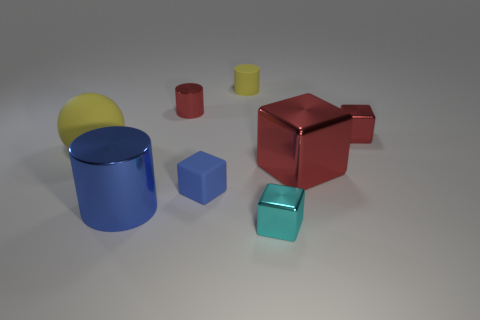What is the material of the red cube that is the same size as the blue rubber cube?
Give a very brief answer. Metal. What number of small red things are there?
Ensure brevity in your answer.  2. There is a red metal cube behind the large yellow thing; what is its size?
Give a very brief answer. Small. Are there the same number of small cyan metallic blocks to the right of the cyan metallic thing and big yellow balls?
Your answer should be compact. No. Are there any big yellow rubber objects of the same shape as the blue matte object?
Offer a terse response. No. There is a shiny thing that is behind the small blue rubber object and left of the big red shiny object; what shape is it?
Your answer should be very brief. Cylinder. Is the large blue cylinder made of the same material as the red cube that is in front of the matte sphere?
Your answer should be very brief. Yes. There is a large cube; are there any tiny things left of it?
Offer a terse response. Yes. How many things are either cyan cylinders or things on the left side of the cyan shiny object?
Offer a terse response. 5. What color is the rubber thing that is behind the small red metal object in front of the red cylinder?
Your response must be concise. Yellow. 